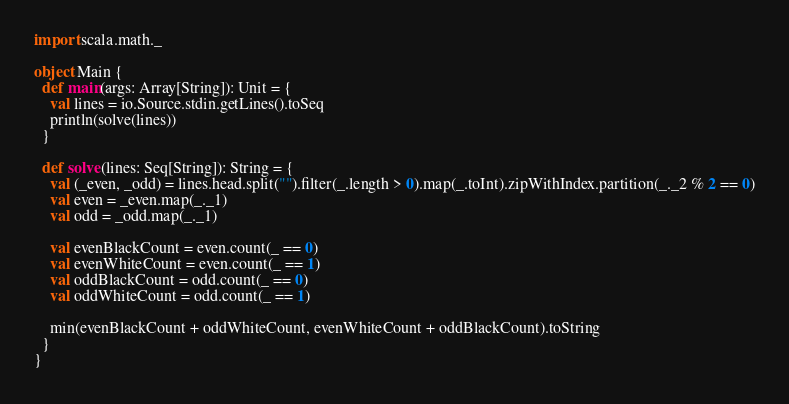<code> <loc_0><loc_0><loc_500><loc_500><_Scala_>import scala.math._

object Main {
  def main(args: Array[String]): Unit = {
    val lines = io.Source.stdin.getLines().toSeq
    println(solve(lines))
  }

  def solve(lines: Seq[String]): String = {
    val (_even, _odd) = lines.head.split("").filter(_.length > 0).map(_.toInt).zipWithIndex.partition(_._2 % 2 == 0)
    val even = _even.map(_._1)
    val odd = _odd.map(_._1)

    val evenBlackCount = even.count(_ == 0)
    val evenWhiteCount = even.count(_ == 1)
    val oddBlackCount = odd.count(_ == 0)
    val oddWhiteCount = odd.count(_ == 1)

    min(evenBlackCount + oddWhiteCount, evenWhiteCount + oddBlackCount).toString
  }
}
</code> 